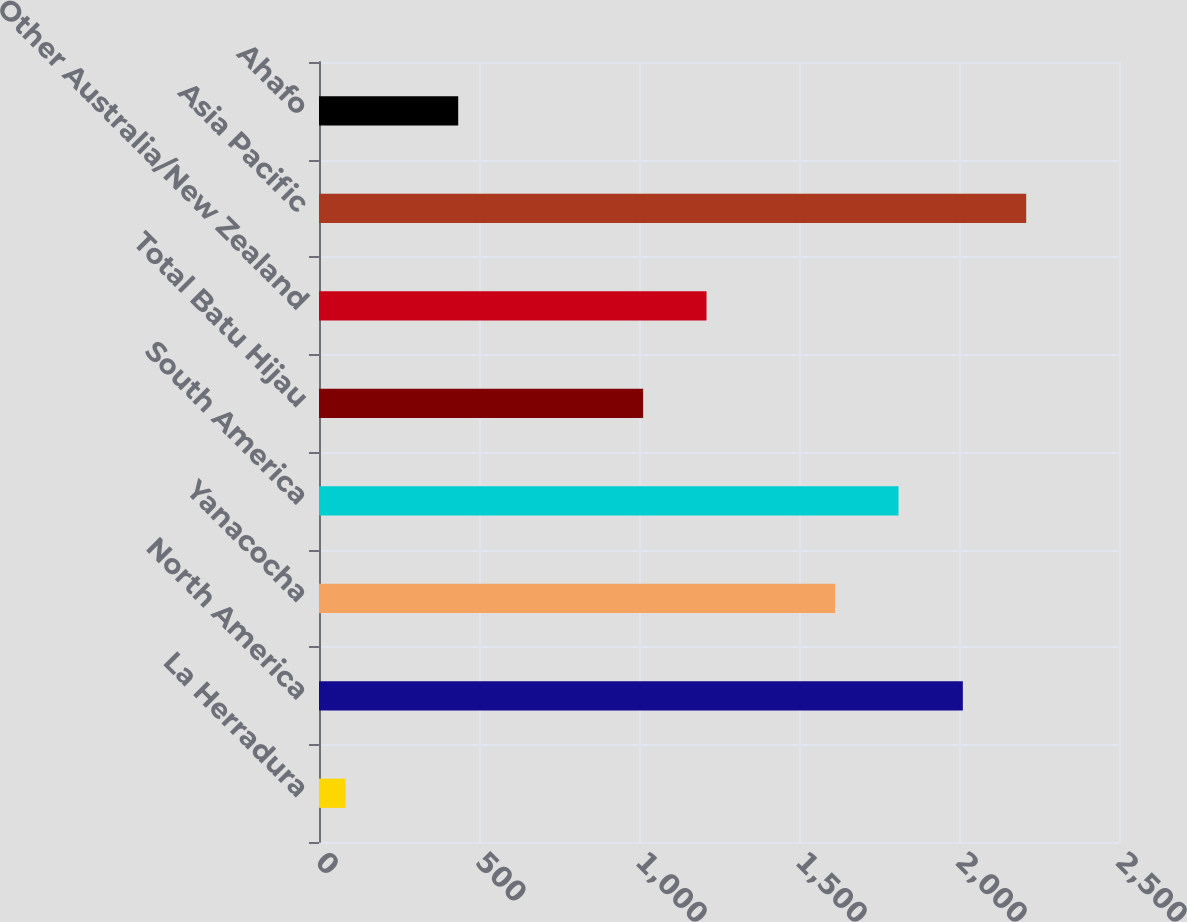Convert chart. <chart><loc_0><loc_0><loc_500><loc_500><bar_chart><fcel>La Herradura<fcel>North America<fcel>Yanacocha<fcel>South America<fcel>Total Batu Hijau<fcel>Other Australia/New Zealand<fcel>Asia Pacific<fcel>Ahafo<nl><fcel>83<fcel>2012<fcel>1613<fcel>1811<fcel>1013<fcel>1211<fcel>2210<fcel>435<nl></chart> 